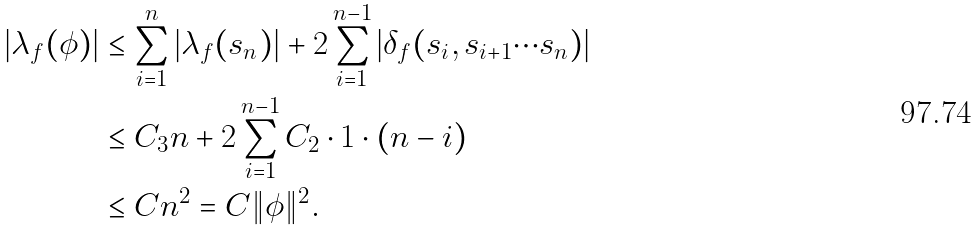Convert formula to latex. <formula><loc_0><loc_0><loc_500><loc_500>| \lambda _ { f } ( \phi ) | & \leq \sum _ { i = 1 } ^ { n } | \lambda _ { f } ( s _ { n } ) | + 2 \sum _ { i = 1 } ^ { n - 1 } | \delta _ { f } ( s _ { i } , s _ { i + 1 } \cdots s _ { n } ) | \\ & \leq C _ { 3 } n + 2 \sum _ { i = 1 } ^ { n - 1 } C _ { 2 } \cdot 1 \cdot ( n - i ) \\ & \leq C n ^ { 2 } = C \| \phi \| ^ { 2 } .</formula> 